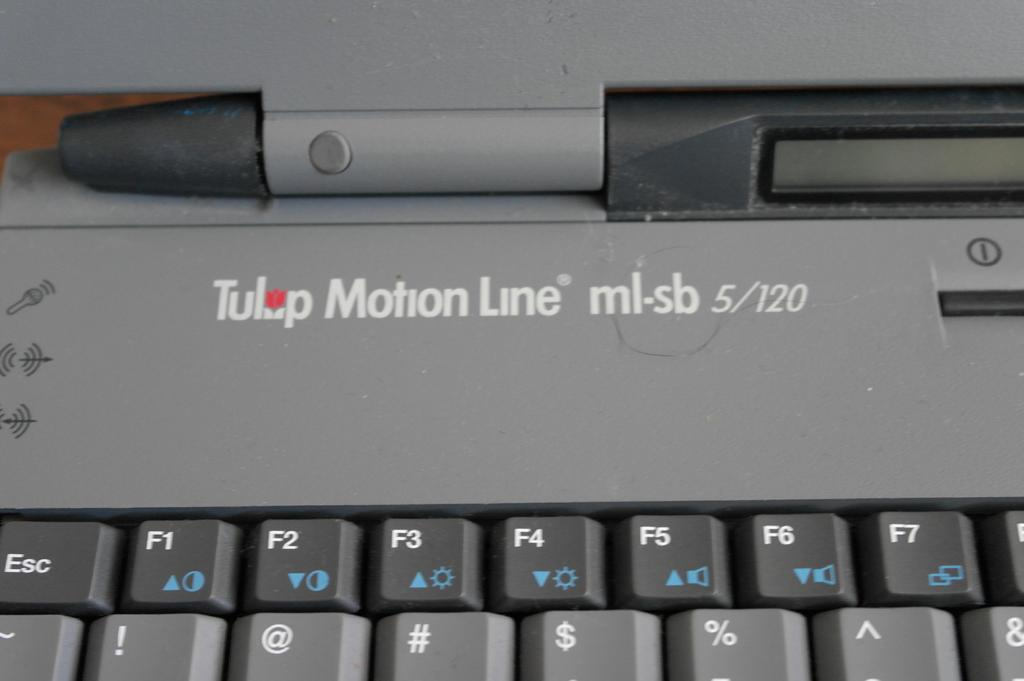Provide a one-sentence caption for the provided image. A keyboard has the name Tulip Motion Line written above the F-number keys. 